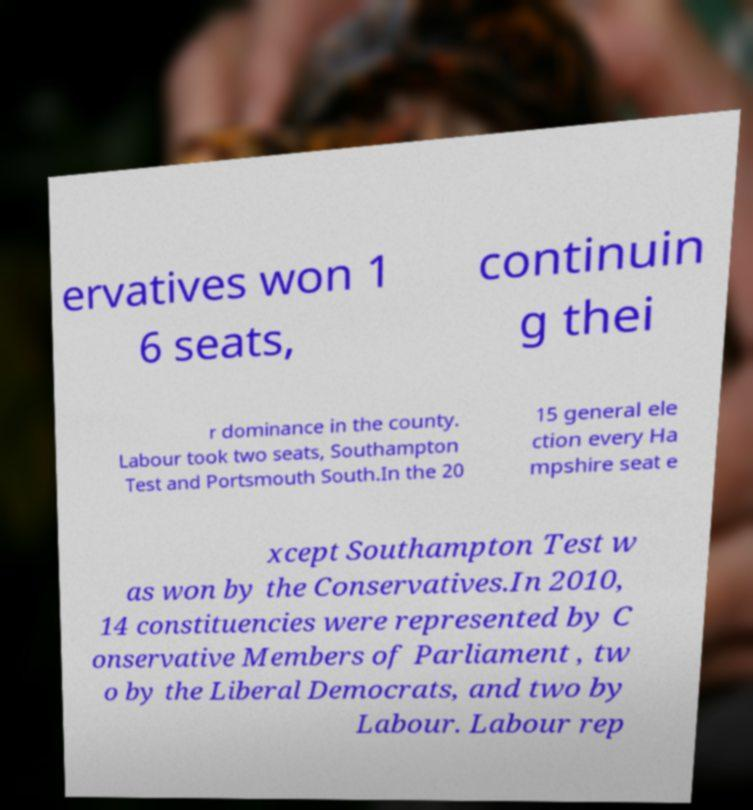What messages or text are displayed in this image? I need them in a readable, typed format. ervatives won 1 6 seats, continuin g thei r dominance in the county. Labour took two seats, Southampton Test and Portsmouth South.In the 20 15 general ele ction every Ha mpshire seat e xcept Southampton Test w as won by the Conservatives.In 2010, 14 constituencies were represented by C onservative Members of Parliament , tw o by the Liberal Democrats, and two by Labour. Labour rep 